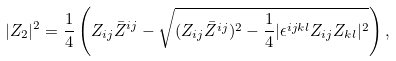<formula> <loc_0><loc_0><loc_500><loc_500>| Z _ { 2 } | ^ { 2 } = { \frac { 1 } { 4 } } \left ( Z _ { i j } \bar { Z } ^ { i j } - \sqrt { ( Z _ { i j } \bar { Z } ^ { i j } ) ^ { 2 } - { \frac { 1 } { 4 } } | \epsilon ^ { i j k l } Z _ { i j } Z _ { k l } | ^ { 2 } } \right ) ,</formula> 